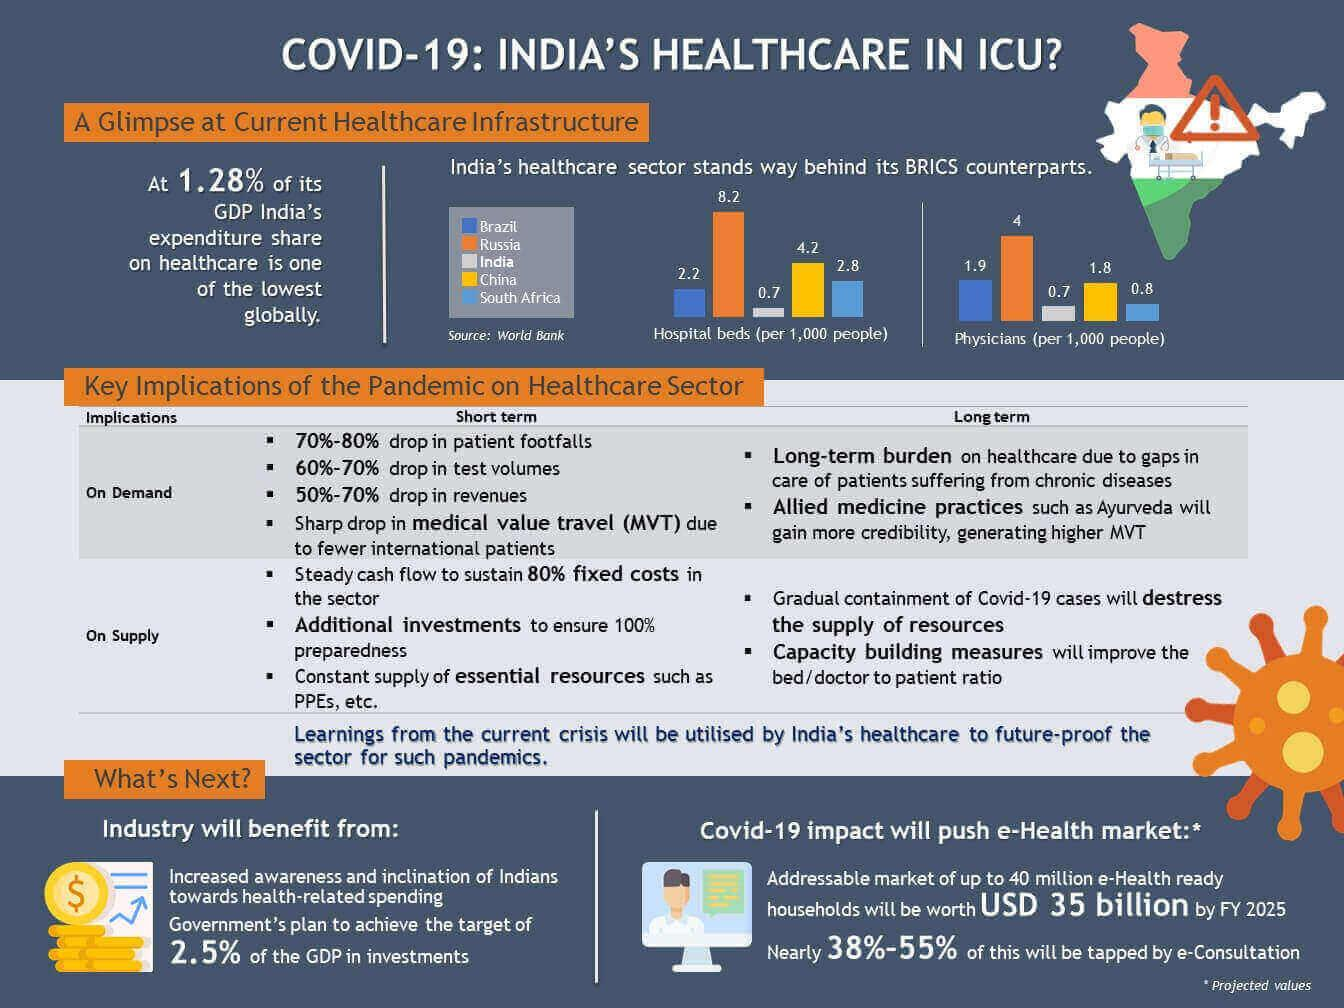Give some essential details in this illustration. In China, there are approximately 1.8 physicians available per 1000 people. According to recent data, there are approximately 8.2 hospital beds available per 1,000 people in Russia. 